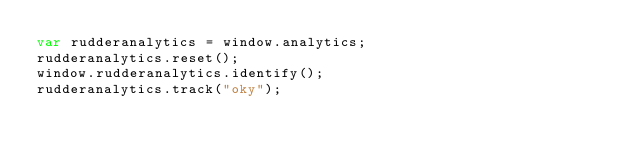<code> <loc_0><loc_0><loc_500><loc_500><_JavaScript_>var rudderanalytics = window.analytics;
rudderanalytics.reset();
window.rudderanalytics.identify();
rudderanalytics.track("oky");
</code> 